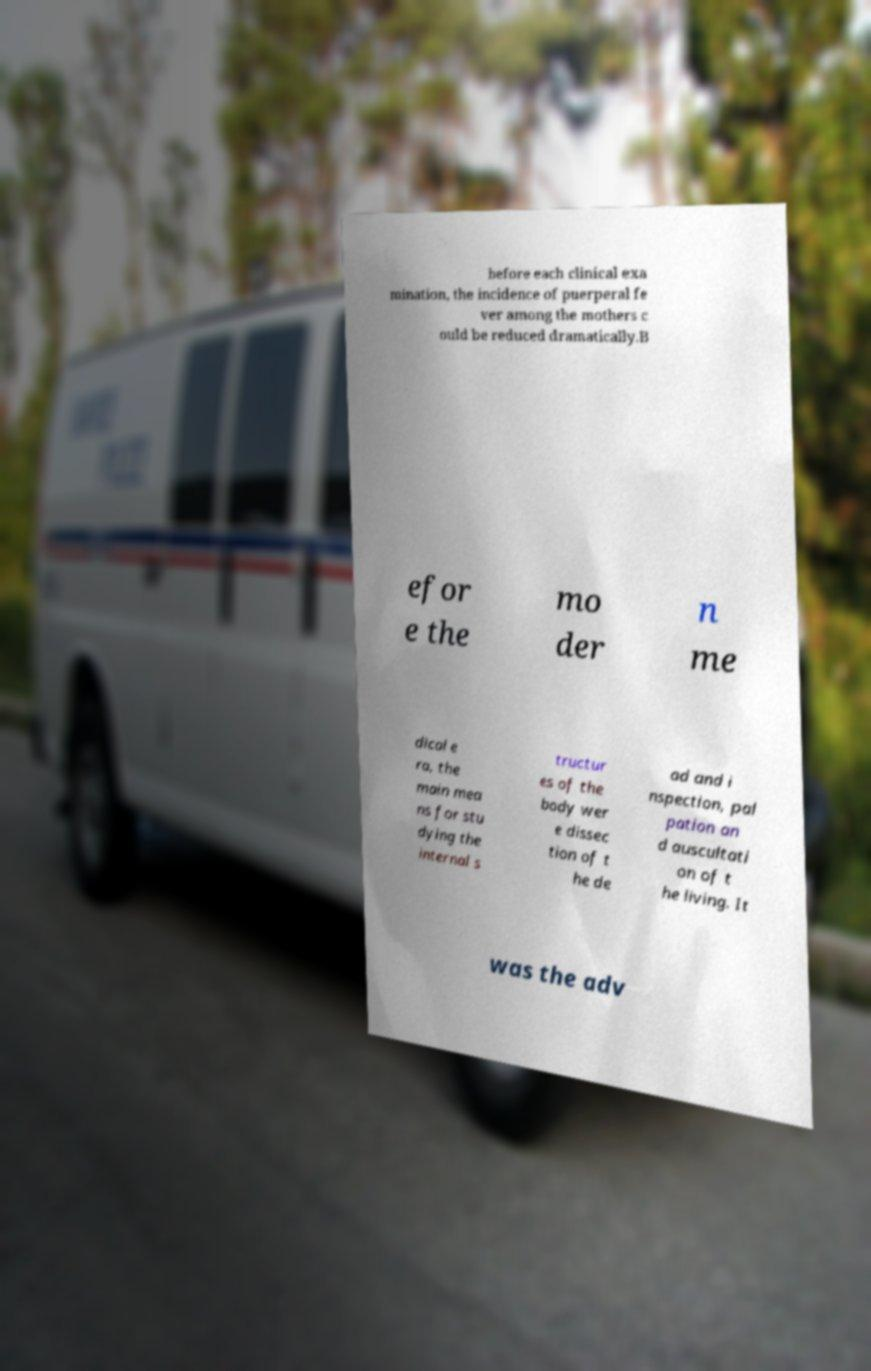Please read and relay the text visible in this image. What does it say? before each clinical exa mination, the incidence of puerperal fe ver among the mothers c ould be reduced dramatically.B efor e the mo der n me dical e ra, the main mea ns for stu dying the internal s tructur es of the body wer e dissec tion of t he de ad and i nspection, pal pation an d auscultati on of t he living. It was the adv 